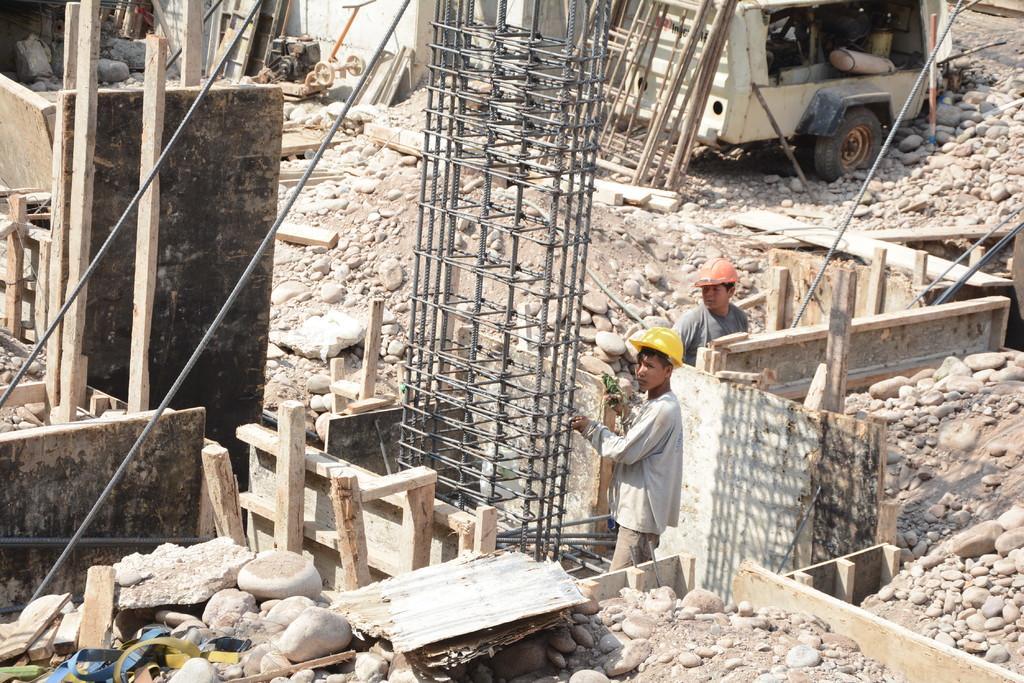Could you give a brief overview of what you see in this image? In this image we can see the vehicle, metal sheets, wooden objects, stones, pebbles, rocks and soil. In the middle of the image we can see two boys are standing. They are wearing helmet. 